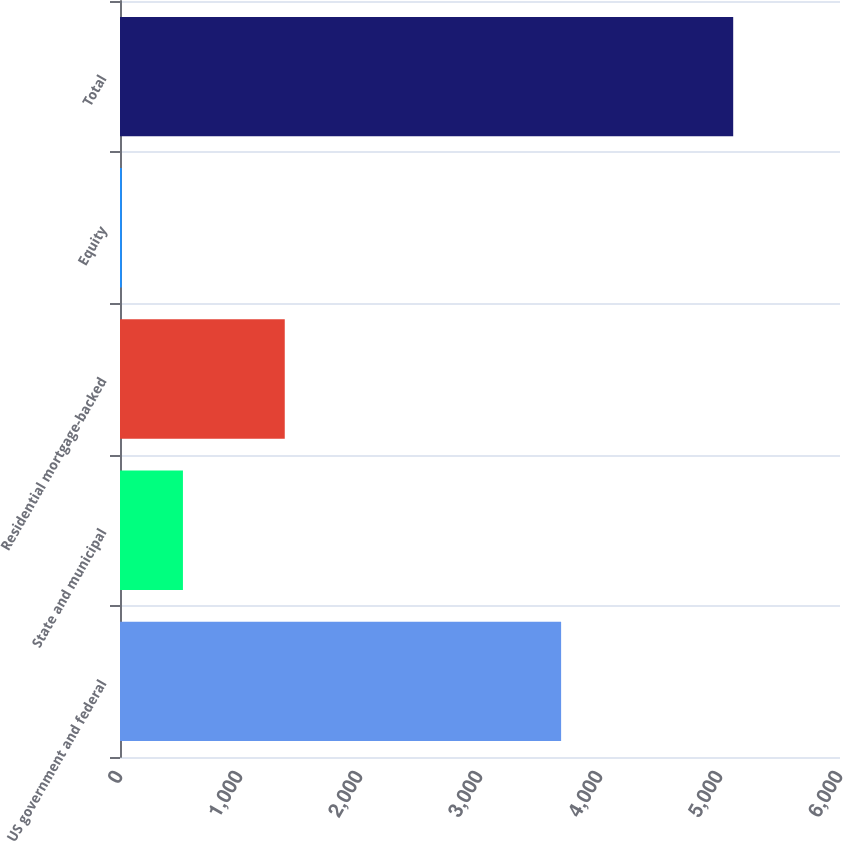Convert chart to OTSL. <chart><loc_0><loc_0><loc_500><loc_500><bar_chart><fcel>US government and federal<fcel>State and municipal<fcel>Residential mortgage-backed<fcel>Equity<fcel>Total<nl><fcel>3676<fcel>524.5<fcel>1373<fcel>15<fcel>5110<nl></chart> 